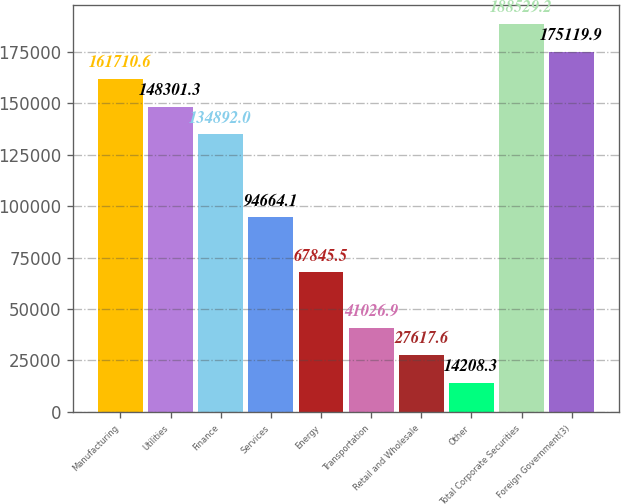Convert chart to OTSL. <chart><loc_0><loc_0><loc_500><loc_500><bar_chart><fcel>Manufacturing<fcel>Utilities<fcel>Finance<fcel>Services<fcel>Energy<fcel>Transportation<fcel>Retail and Wholesale<fcel>Other<fcel>Total Corporate Securities<fcel>Foreign Government(3)<nl><fcel>161711<fcel>148301<fcel>134892<fcel>94664.1<fcel>67845.5<fcel>41026.9<fcel>27617.6<fcel>14208.3<fcel>188529<fcel>175120<nl></chart> 